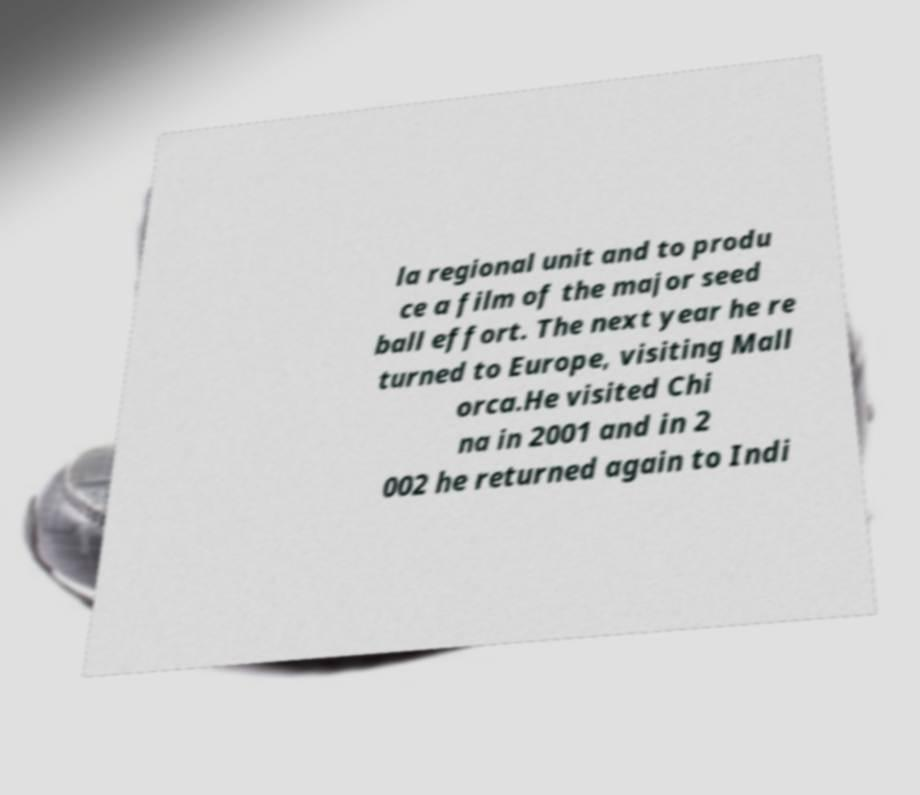What messages or text are displayed in this image? I need them in a readable, typed format. la regional unit and to produ ce a film of the major seed ball effort. The next year he re turned to Europe, visiting Mall orca.He visited Chi na in 2001 and in 2 002 he returned again to Indi 